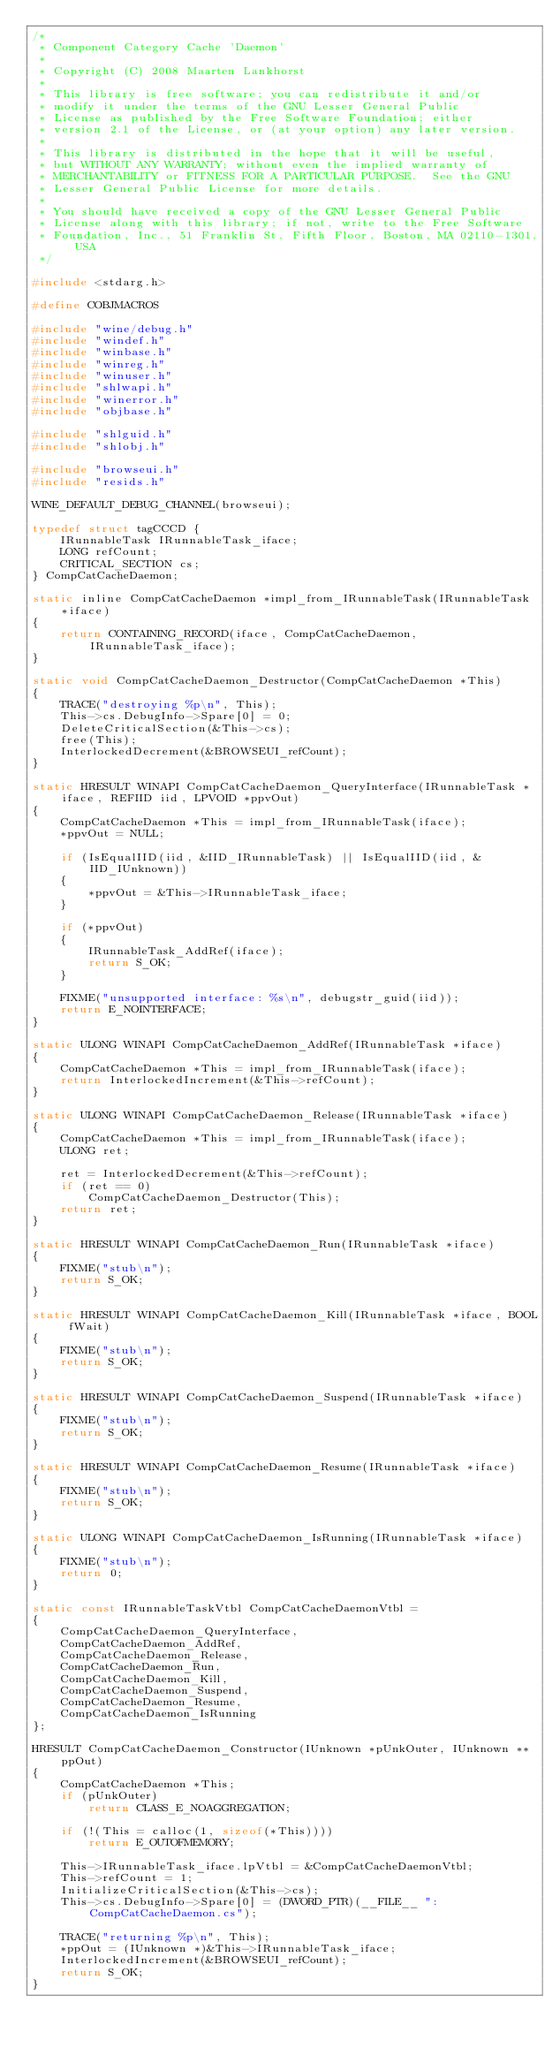Convert code to text. <code><loc_0><loc_0><loc_500><loc_500><_C_>/*
 * Component Category Cache 'Daemon'
 *
 * Copyright (C) 2008 Maarten Lankhorst
 *
 * This library is free software; you can redistribute it and/or
 * modify it under the terms of the GNU Lesser General Public
 * License as published by the Free Software Foundation; either
 * version 2.1 of the License, or (at your option) any later version.
 *
 * This library is distributed in the hope that it will be useful,
 * but WITHOUT ANY WARRANTY; without even the implied warranty of
 * MERCHANTABILITY or FITNESS FOR A PARTICULAR PURPOSE.  See the GNU
 * Lesser General Public License for more details.
 *
 * You should have received a copy of the GNU Lesser General Public
 * License along with this library; if not, write to the Free Software
 * Foundation, Inc., 51 Franklin St, Fifth Floor, Boston, MA 02110-1301, USA
 */

#include <stdarg.h>

#define COBJMACROS

#include "wine/debug.h"
#include "windef.h"
#include "winbase.h"
#include "winreg.h"
#include "winuser.h"
#include "shlwapi.h"
#include "winerror.h"
#include "objbase.h"

#include "shlguid.h"
#include "shlobj.h"

#include "browseui.h"
#include "resids.h"

WINE_DEFAULT_DEBUG_CHANNEL(browseui);

typedef struct tagCCCD {
    IRunnableTask IRunnableTask_iface;
    LONG refCount;
    CRITICAL_SECTION cs;
} CompCatCacheDaemon;

static inline CompCatCacheDaemon *impl_from_IRunnableTask(IRunnableTask *iface)
{
    return CONTAINING_RECORD(iface, CompCatCacheDaemon, IRunnableTask_iface);
}

static void CompCatCacheDaemon_Destructor(CompCatCacheDaemon *This)
{
    TRACE("destroying %p\n", This);
    This->cs.DebugInfo->Spare[0] = 0;
    DeleteCriticalSection(&This->cs);
    free(This);
    InterlockedDecrement(&BROWSEUI_refCount);
}

static HRESULT WINAPI CompCatCacheDaemon_QueryInterface(IRunnableTask *iface, REFIID iid, LPVOID *ppvOut)
{
    CompCatCacheDaemon *This = impl_from_IRunnableTask(iface);
    *ppvOut = NULL;

    if (IsEqualIID(iid, &IID_IRunnableTask) || IsEqualIID(iid, &IID_IUnknown))
    {
        *ppvOut = &This->IRunnableTask_iface;
    }

    if (*ppvOut)
    {
        IRunnableTask_AddRef(iface);
        return S_OK;
    }

    FIXME("unsupported interface: %s\n", debugstr_guid(iid));
    return E_NOINTERFACE;
}

static ULONG WINAPI CompCatCacheDaemon_AddRef(IRunnableTask *iface)
{
    CompCatCacheDaemon *This = impl_from_IRunnableTask(iface);
    return InterlockedIncrement(&This->refCount);
}

static ULONG WINAPI CompCatCacheDaemon_Release(IRunnableTask *iface)
{
    CompCatCacheDaemon *This = impl_from_IRunnableTask(iface);
    ULONG ret;

    ret = InterlockedDecrement(&This->refCount);
    if (ret == 0)
        CompCatCacheDaemon_Destructor(This);
    return ret;
}

static HRESULT WINAPI CompCatCacheDaemon_Run(IRunnableTask *iface)
{
    FIXME("stub\n");
    return S_OK;
}

static HRESULT WINAPI CompCatCacheDaemon_Kill(IRunnableTask *iface, BOOL fWait)
{
    FIXME("stub\n");
    return S_OK;
}

static HRESULT WINAPI CompCatCacheDaemon_Suspend(IRunnableTask *iface)
{
    FIXME("stub\n");
    return S_OK;
}

static HRESULT WINAPI CompCatCacheDaemon_Resume(IRunnableTask *iface)
{
    FIXME("stub\n");
    return S_OK;
}

static ULONG WINAPI CompCatCacheDaemon_IsRunning(IRunnableTask *iface)
{
    FIXME("stub\n");
    return 0;
}

static const IRunnableTaskVtbl CompCatCacheDaemonVtbl =
{
    CompCatCacheDaemon_QueryInterface,
    CompCatCacheDaemon_AddRef,
    CompCatCacheDaemon_Release,
    CompCatCacheDaemon_Run,
    CompCatCacheDaemon_Kill,
    CompCatCacheDaemon_Suspend,
    CompCatCacheDaemon_Resume,
    CompCatCacheDaemon_IsRunning
};

HRESULT CompCatCacheDaemon_Constructor(IUnknown *pUnkOuter, IUnknown **ppOut)
{
    CompCatCacheDaemon *This;
    if (pUnkOuter)
        return CLASS_E_NOAGGREGATION;

    if (!(This = calloc(1, sizeof(*This))))
        return E_OUTOFMEMORY;

    This->IRunnableTask_iface.lpVtbl = &CompCatCacheDaemonVtbl;
    This->refCount = 1;
    InitializeCriticalSection(&This->cs);
    This->cs.DebugInfo->Spare[0] = (DWORD_PTR)(__FILE__ ": CompCatCacheDaemon.cs");

    TRACE("returning %p\n", This);
    *ppOut = (IUnknown *)&This->IRunnableTask_iface;
    InterlockedIncrement(&BROWSEUI_refCount);
    return S_OK;
}
</code> 